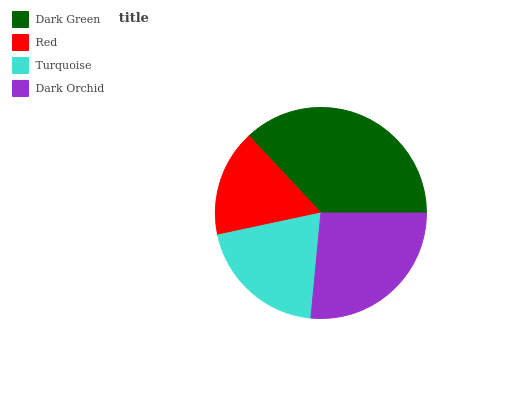Is Red the minimum?
Answer yes or no. Yes. Is Dark Green the maximum?
Answer yes or no. Yes. Is Turquoise the minimum?
Answer yes or no. No. Is Turquoise the maximum?
Answer yes or no. No. Is Turquoise greater than Red?
Answer yes or no. Yes. Is Red less than Turquoise?
Answer yes or no. Yes. Is Red greater than Turquoise?
Answer yes or no. No. Is Turquoise less than Red?
Answer yes or no. No. Is Dark Orchid the high median?
Answer yes or no. Yes. Is Turquoise the low median?
Answer yes or no. Yes. Is Dark Green the high median?
Answer yes or no. No. Is Red the low median?
Answer yes or no. No. 